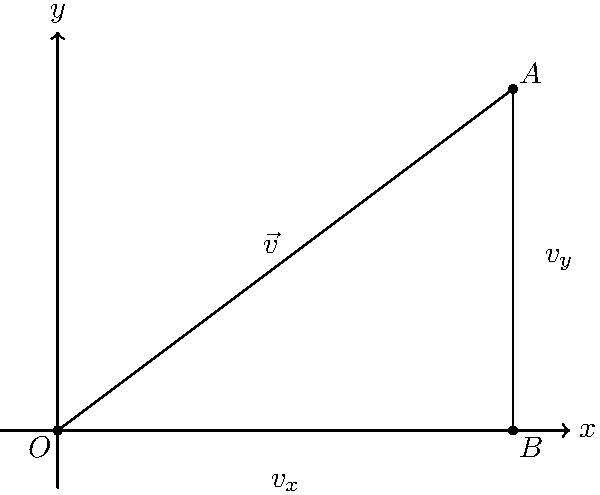An industrial conveyor belt in a manufacturing plant moves with a velocity vector $\vec{v}$ represented by the hypotenuse of a right triangle. If the x-component of the velocity is 4 m/s and the y-component is 3 m/s, calculate:

a) The magnitude of the velocity vector $\vec{v}$.
b) The angle $\theta$ that the conveyor belt makes with the horizontal (x-axis).

Express your answers in standard units and round to two decimal places. Let's approach this problem step by step:

1) We are given a right triangle where:
   $v_x = 4$ m/s (x-component)
   $v_y = 3$ m/s (y-component)

2) To find the magnitude of $\vec{v}$, we can use the Pythagorean theorem:

   $|\vec{v}| = \sqrt{v_x^2 + v_y^2}$

   $|\vec{v}| = \sqrt{4^2 + 3^2}$
   
   $|\vec{v}| = \sqrt{16 + 9} = \sqrt{25} = 5$ m/s

3) To find the angle $\theta$, we can use the arctangent function:

   $\theta = \tan^{-1}(\frac{v_y}{v_x})$

   $\theta = \tan^{-1}(\frac{3}{4})$

   $\theta = 36.87°$

Therefore:
a) The magnitude of the velocity vector is 5 m/s.
b) The angle the conveyor belt makes with the horizontal is 36.87°.
Answer: a) 5.00 m/s
b) 36.87° 